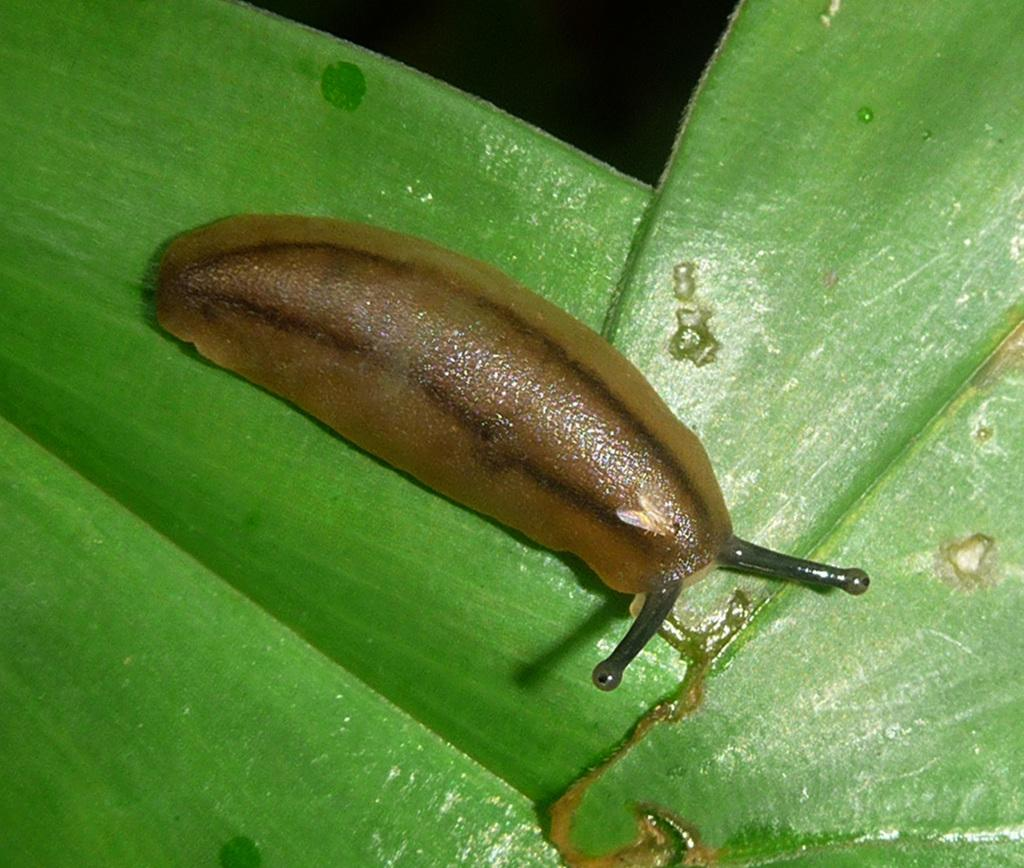What type of animal is in the image? There is a snail in the image. Where is the snail located? The snail is on a green leaf. What color can be seen in the image besides the green leaf? There is black color visible in the image. What type of hair can be seen on the snail in the image? There is no hair visible on the snail in the image. What type of thing is the snail using to cut the leaf in the image? The snail is not using any type of thing to cut the leaf in the image; it is simply on the leaf. 